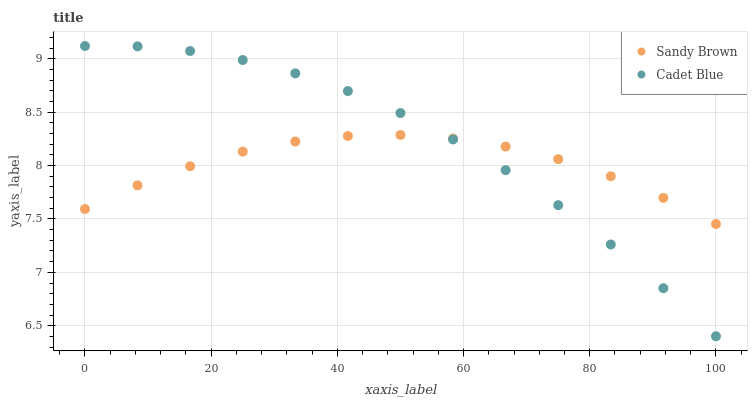Does Sandy Brown have the minimum area under the curve?
Answer yes or no. Yes. Does Cadet Blue have the maximum area under the curve?
Answer yes or no. Yes. Does Sandy Brown have the maximum area under the curve?
Answer yes or no. No. Is Cadet Blue the smoothest?
Answer yes or no. Yes. Is Sandy Brown the roughest?
Answer yes or no. Yes. Is Sandy Brown the smoothest?
Answer yes or no. No. Does Cadet Blue have the lowest value?
Answer yes or no. Yes. Does Sandy Brown have the lowest value?
Answer yes or no. No. Does Cadet Blue have the highest value?
Answer yes or no. Yes. Does Sandy Brown have the highest value?
Answer yes or no. No. Does Cadet Blue intersect Sandy Brown?
Answer yes or no. Yes. Is Cadet Blue less than Sandy Brown?
Answer yes or no. No. Is Cadet Blue greater than Sandy Brown?
Answer yes or no. No. 